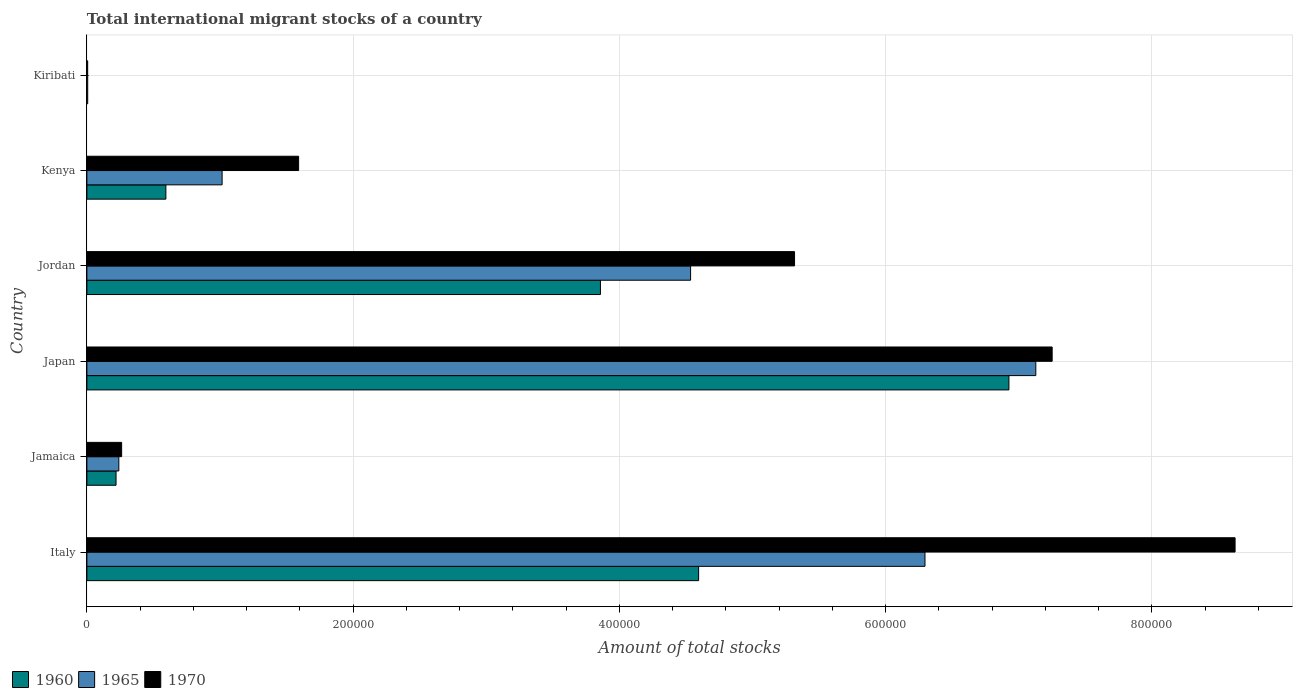How many groups of bars are there?
Provide a short and direct response. 6. Are the number of bars per tick equal to the number of legend labels?
Your answer should be very brief. Yes. Are the number of bars on each tick of the Y-axis equal?
Offer a very short reply. Yes. How many bars are there on the 1st tick from the top?
Your answer should be very brief. 3. What is the label of the 2nd group of bars from the top?
Provide a succinct answer. Kenya. In how many cases, is the number of bars for a given country not equal to the number of legend labels?
Make the answer very short. 0. What is the amount of total stocks in in 1960 in Jamaica?
Make the answer very short. 2.19e+04. Across all countries, what is the maximum amount of total stocks in in 1970?
Ensure brevity in your answer.  8.63e+05. Across all countries, what is the minimum amount of total stocks in in 1965?
Offer a very short reply. 602. In which country was the amount of total stocks in in 1970 minimum?
Keep it short and to the point. Kiribati. What is the total amount of total stocks in in 1970 in the graph?
Your response must be concise. 2.31e+06. What is the difference between the amount of total stocks in in 1960 in Italy and that in Kenya?
Keep it short and to the point. 4.00e+05. What is the difference between the amount of total stocks in in 1965 in Jordan and the amount of total stocks in in 1970 in Kenya?
Provide a short and direct response. 2.94e+05. What is the average amount of total stocks in in 1970 per country?
Offer a very short reply. 3.84e+05. What is the ratio of the amount of total stocks in in 1960 in Jamaica to that in Jordan?
Give a very brief answer. 0.06. Is the difference between the amount of total stocks in in 1960 in Jamaica and Kenya greater than the difference between the amount of total stocks in in 1970 in Jamaica and Kenya?
Make the answer very short. Yes. What is the difference between the highest and the second highest amount of total stocks in in 1960?
Your answer should be compact. 2.33e+05. What is the difference between the highest and the lowest amount of total stocks in in 1970?
Provide a succinct answer. 8.62e+05. What does the 1st bar from the top in Jordan represents?
Offer a very short reply. 1970. Is it the case that in every country, the sum of the amount of total stocks in in 1970 and amount of total stocks in in 1960 is greater than the amount of total stocks in in 1965?
Provide a succinct answer. Yes. How many bars are there?
Make the answer very short. 18. Are all the bars in the graph horizontal?
Ensure brevity in your answer.  Yes. How many countries are there in the graph?
Give a very brief answer. 6. What is the difference between two consecutive major ticks on the X-axis?
Offer a terse response. 2.00e+05. Are the values on the major ticks of X-axis written in scientific E-notation?
Your answer should be very brief. No. Does the graph contain any zero values?
Provide a succinct answer. No. How many legend labels are there?
Your response must be concise. 3. What is the title of the graph?
Offer a very short reply. Total international migrant stocks of a country. What is the label or title of the X-axis?
Your answer should be very brief. Amount of total stocks. What is the label or title of the Y-axis?
Make the answer very short. Country. What is the Amount of total stocks of 1960 in Italy?
Your answer should be very brief. 4.60e+05. What is the Amount of total stocks of 1965 in Italy?
Offer a terse response. 6.30e+05. What is the Amount of total stocks of 1970 in Italy?
Offer a terse response. 8.63e+05. What is the Amount of total stocks in 1960 in Jamaica?
Ensure brevity in your answer.  2.19e+04. What is the Amount of total stocks in 1965 in Jamaica?
Offer a very short reply. 2.40e+04. What is the Amount of total stocks of 1970 in Jamaica?
Keep it short and to the point. 2.61e+04. What is the Amount of total stocks of 1960 in Japan?
Keep it short and to the point. 6.93e+05. What is the Amount of total stocks in 1965 in Japan?
Make the answer very short. 7.13e+05. What is the Amount of total stocks in 1970 in Japan?
Make the answer very short. 7.25e+05. What is the Amount of total stocks in 1960 in Jordan?
Offer a very short reply. 3.86e+05. What is the Amount of total stocks in 1965 in Jordan?
Your answer should be very brief. 4.54e+05. What is the Amount of total stocks in 1970 in Jordan?
Offer a very short reply. 5.32e+05. What is the Amount of total stocks in 1960 in Kenya?
Your answer should be very brief. 5.93e+04. What is the Amount of total stocks of 1965 in Kenya?
Keep it short and to the point. 1.02e+05. What is the Amount of total stocks of 1970 in Kenya?
Your response must be concise. 1.59e+05. What is the Amount of total stocks in 1960 in Kiribati?
Your answer should be compact. 610. What is the Amount of total stocks in 1965 in Kiribati?
Your answer should be compact. 602. What is the Amount of total stocks of 1970 in Kiribati?
Offer a very short reply. 587. Across all countries, what is the maximum Amount of total stocks in 1960?
Your answer should be very brief. 6.93e+05. Across all countries, what is the maximum Amount of total stocks of 1965?
Give a very brief answer. 7.13e+05. Across all countries, what is the maximum Amount of total stocks in 1970?
Your response must be concise. 8.63e+05. Across all countries, what is the minimum Amount of total stocks of 1960?
Offer a terse response. 610. Across all countries, what is the minimum Amount of total stocks in 1965?
Give a very brief answer. 602. Across all countries, what is the minimum Amount of total stocks in 1970?
Offer a terse response. 587. What is the total Amount of total stocks of 1960 in the graph?
Give a very brief answer. 1.62e+06. What is the total Amount of total stocks of 1965 in the graph?
Provide a short and direct response. 1.92e+06. What is the total Amount of total stocks of 1970 in the graph?
Provide a short and direct response. 2.31e+06. What is the difference between the Amount of total stocks in 1960 in Italy and that in Jamaica?
Your answer should be very brief. 4.38e+05. What is the difference between the Amount of total stocks of 1965 in Italy and that in Jamaica?
Your answer should be very brief. 6.06e+05. What is the difference between the Amount of total stocks in 1970 in Italy and that in Jamaica?
Make the answer very short. 8.36e+05. What is the difference between the Amount of total stocks in 1960 in Italy and that in Japan?
Offer a terse response. -2.33e+05. What is the difference between the Amount of total stocks of 1965 in Italy and that in Japan?
Make the answer very short. -8.33e+04. What is the difference between the Amount of total stocks in 1970 in Italy and that in Japan?
Your response must be concise. 1.37e+05. What is the difference between the Amount of total stocks in 1960 in Italy and that in Jordan?
Provide a succinct answer. 7.38e+04. What is the difference between the Amount of total stocks in 1965 in Italy and that in Jordan?
Your response must be concise. 1.76e+05. What is the difference between the Amount of total stocks in 1970 in Italy and that in Jordan?
Make the answer very short. 3.31e+05. What is the difference between the Amount of total stocks in 1960 in Italy and that in Kenya?
Your answer should be compact. 4.00e+05. What is the difference between the Amount of total stocks in 1965 in Italy and that in Kenya?
Keep it short and to the point. 5.28e+05. What is the difference between the Amount of total stocks in 1970 in Italy and that in Kenya?
Give a very brief answer. 7.04e+05. What is the difference between the Amount of total stocks in 1960 in Italy and that in Kiribati?
Your answer should be compact. 4.59e+05. What is the difference between the Amount of total stocks in 1965 in Italy and that in Kiribati?
Give a very brief answer. 6.29e+05. What is the difference between the Amount of total stocks in 1970 in Italy and that in Kiribati?
Make the answer very short. 8.62e+05. What is the difference between the Amount of total stocks of 1960 in Jamaica and that in Japan?
Provide a short and direct response. -6.71e+05. What is the difference between the Amount of total stocks of 1965 in Jamaica and that in Japan?
Your answer should be compact. -6.89e+05. What is the difference between the Amount of total stocks in 1970 in Jamaica and that in Japan?
Ensure brevity in your answer.  -6.99e+05. What is the difference between the Amount of total stocks of 1960 in Jamaica and that in Jordan?
Ensure brevity in your answer.  -3.64e+05. What is the difference between the Amount of total stocks of 1965 in Jamaica and that in Jordan?
Provide a succinct answer. -4.30e+05. What is the difference between the Amount of total stocks in 1970 in Jamaica and that in Jordan?
Your answer should be very brief. -5.06e+05. What is the difference between the Amount of total stocks in 1960 in Jamaica and that in Kenya?
Offer a terse response. -3.74e+04. What is the difference between the Amount of total stocks in 1965 in Jamaica and that in Kenya?
Offer a terse response. -7.76e+04. What is the difference between the Amount of total stocks of 1970 in Jamaica and that in Kenya?
Offer a very short reply. -1.33e+05. What is the difference between the Amount of total stocks in 1960 in Jamaica and that in Kiribati?
Offer a very short reply. 2.13e+04. What is the difference between the Amount of total stocks in 1965 in Jamaica and that in Kiribati?
Make the answer very short. 2.34e+04. What is the difference between the Amount of total stocks in 1970 in Jamaica and that in Kiribati?
Offer a terse response. 2.55e+04. What is the difference between the Amount of total stocks in 1960 in Japan and that in Jordan?
Provide a succinct answer. 3.07e+05. What is the difference between the Amount of total stocks in 1965 in Japan and that in Jordan?
Offer a terse response. 2.59e+05. What is the difference between the Amount of total stocks of 1970 in Japan and that in Jordan?
Give a very brief answer. 1.94e+05. What is the difference between the Amount of total stocks in 1960 in Japan and that in Kenya?
Your response must be concise. 6.33e+05. What is the difference between the Amount of total stocks of 1965 in Japan and that in Kenya?
Provide a succinct answer. 6.11e+05. What is the difference between the Amount of total stocks in 1970 in Japan and that in Kenya?
Keep it short and to the point. 5.66e+05. What is the difference between the Amount of total stocks in 1960 in Japan and that in Kiribati?
Make the answer very short. 6.92e+05. What is the difference between the Amount of total stocks in 1965 in Japan and that in Kiribati?
Provide a succinct answer. 7.12e+05. What is the difference between the Amount of total stocks of 1970 in Japan and that in Kiribati?
Give a very brief answer. 7.25e+05. What is the difference between the Amount of total stocks in 1960 in Jordan and that in Kenya?
Offer a terse response. 3.26e+05. What is the difference between the Amount of total stocks of 1965 in Jordan and that in Kenya?
Your answer should be very brief. 3.52e+05. What is the difference between the Amount of total stocks of 1970 in Jordan and that in Kenya?
Provide a succinct answer. 3.73e+05. What is the difference between the Amount of total stocks of 1960 in Jordan and that in Kiribati?
Your answer should be compact. 3.85e+05. What is the difference between the Amount of total stocks of 1965 in Jordan and that in Kiribati?
Offer a terse response. 4.53e+05. What is the difference between the Amount of total stocks of 1970 in Jordan and that in Kiribati?
Provide a short and direct response. 5.31e+05. What is the difference between the Amount of total stocks in 1960 in Kenya and that in Kiribati?
Provide a short and direct response. 5.87e+04. What is the difference between the Amount of total stocks of 1965 in Kenya and that in Kiribati?
Your answer should be very brief. 1.01e+05. What is the difference between the Amount of total stocks in 1970 in Kenya and that in Kiribati?
Make the answer very short. 1.58e+05. What is the difference between the Amount of total stocks in 1960 in Italy and the Amount of total stocks in 1965 in Jamaica?
Your response must be concise. 4.36e+05. What is the difference between the Amount of total stocks of 1960 in Italy and the Amount of total stocks of 1970 in Jamaica?
Keep it short and to the point. 4.33e+05. What is the difference between the Amount of total stocks of 1965 in Italy and the Amount of total stocks of 1970 in Jamaica?
Your answer should be compact. 6.03e+05. What is the difference between the Amount of total stocks in 1960 in Italy and the Amount of total stocks in 1965 in Japan?
Keep it short and to the point. -2.53e+05. What is the difference between the Amount of total stocks in 1960 in Italy and the Amount of total stocks in 1970 in Japan?
Keep it short and to the point. -2.66e+05. What is the difference between the Amount of total stocks in 1965 in Italy and the Amount of total stocks in 1970 in Japan?
Keep it short and to the point. -9.55e+04. What is the difference between the Amount of total stocks in 1960 in Italy and the Amount of total stocks in 1965 in Jordan?
Your response must be concise. 6032. What is the difference between the Amount of total stocks in 1960 in Italy and the Amount of total stocks in 1970 in Jordan?
Your response must be concise. -7.21e+04. What is the difference between the Amount of total stocks in 1965 in Italy and the Amount of total stocks in 1970 in Jordan?
Your answer should be very brief. 9.80e+04. What is the difference between the Amount of total stocks in 1960 in Italy and the Amount of total stocks in 1965 in Kenya?
Your answer should be compact. 3.58e+05. What is the difference between the Amount of total stocks in 1960 in Italy and the Amount of total stocks in 1970 in Kenya?
Offer a terse response. 3.01e+05. What is the difference between the Amount of total stocks of 1965 in Italy and the Amount of total stocks of 1970 in Kenya?
Keep it short and to the point. 4.71e+05. What is the difference between the Amount of total stocks in 1960 in Italy and the Amount of total stocks in 1965 in Kiribati?
Provide a short and direct response. 4.59e+05. What is the difference between the Amount of total stocks of 1960 in Italy and the Amount of total stocks of 1970 in Kiribati?
Your answer should be very brief. 4.59e+05. What is the difference between the Amount of total stocks in 1965 in Italy and the Amount of total stocks in 1970 in Kiribati?
Your answer should be compact. 6.29e+05. What is the difference between the Amount of total stocks in 1960 in Jamaica and the Amount of total stocks in 1965 in Japan?
Ensure brevity in your answer.  -6.91e+05. What is the difference between the Amount of total stocks of 1960 in Jamaica and the Amount of total stocks of 1970 in Japan?
Give a very brief answer. -7.03e+05. What is the difference between the Amount of total stocks in 1965 in Jamaica and the Amount of total stocks in 1970 in Japan?
Your response must be concise. -7.01e+05. What is the difference between the Amount of total stocks of 1960 in Jamaica and the Amount of total stocks of 1965 in Jordan?
Your answer should be compact. -4.32e+05. What is the difference between the Amount of total stocks of 1960 in Jamaica and the Amount of total stocks of 1970 in Jordan?
Ensure brevity in your answer.  -5.10e+05. What is the difference between the Amount of total stocks of 1965 in Jamaica and the Amount of total stocks of 1970 in Jordan?
Ensure brevity in your answer.  -5.08e+05. What is the difference between the Amount of total stocks of 1960 in Jamaica and the Amount of total stocks of 1965 in Kenya?
Give a very brief answer. -7.97e+04. What is the difference between the Amount of total stocks of 1960 in Jamaica and the Amount of total stocks of 1970 in Kenya?
Provide a short and direct response. -1.37e+05. What is the difference between the Amount of total stocks of 1965 in Jamaica and the Amount of total stocks of 1970 in Kenya?
Your response must be concise. -1.35e+05. What is the difference between the Amount of total stocks in 1960 in Jamaica and the Amount of total stocks in 1965 in Kiribati?
Provide a succinct answer. 2.13e+04. What is the difference between the Amount of total stocks in 1960 in Jamaica and the Amount of total stocks in 1970 in Kiribati?
Ensure brevity in your answer.  2.13e+04. What is the difference between the Amount of total stocks of 1965 in Jamaica and the Amount of total stocks of 1970 in Kiribati?
Provide a short and direct response. 2.34e+04. What is the difference between the Amount of total stocks in 1960 in Japan and the Amount of total stocks in 1965 in Jordan?
Provide a succinct answer. 2.39e+05. What is the difference between the Amount of total stocks of 1960 in Japan and the Amount of total stocks of 1970 in Jordan?
Ensure brevity in your answer.  1.61e+05. What is the difference between the Amount of total stocks of 1965 in Japan and the Amount of total stocks of 1970 in Jordan?
Your response must be concise. 1.81e+05. What is the difference between the Amount of total stocks of 1960 in Japan and the Amount of total stocks of 1965 in Kenya?
Your answer should be very brief. 5.91e+05. What is the difference between the Amount of total stocks of 1960 in Japan and the Amount of total stocks of 1970 in Kenya?
Keep it short and to the point. 5.34e+05. What is the difference between the Amount of total stocks in 1965 in Japan and the Amount of total stocks in 1970 in Kenya?
Your response must be concise. 5.54e+05. What is the difference between the Amount of total stocks in 1960 in Japan and the Amount of total stocks in 1965 in Kiribati?
Keep it short and to the point. 6.92e+05. What is the difference between the Amount of total stocks in 1960 in Japan and the Amount of total stocks in 1970 in Kiribati?
Offer a terse response. 6.92e+05. What is the difference between the Amount of total stocks of 1965 in Japan and the Amount of total stocks of 1970 in Kiribati?
Your response must be concise. 7.12e+05. What is the difference between the Amount of total stocks in 1960 in Jordan and the Amount of total stocks in 1965 in Kenya?
Your answer should be very brief. 2.84e+05. What is the difference between the Amount of total stocks in 1960 in Jordan and the Amount of total stocks in 1970 in Kenya?
Provide a short and direct response. 2.27e+05. What is the difference between the Amount of total stocks of 1965 in Jordan and the Amount of total stocks of 1970 in Kenya?
Your response must be concise. 2.94e+05. What is the difference between the Amount of total stocks in 1960 in Jordan and the Amount of total stocks in 1965 in Kiribati?
Offer a very short reply. 3.85e+05. What is the difference between the Amount of total stocks in 1960 in Jordan and the Amount of total stocks in 1970 in Kiribati?
Your answer should be compact. 3.85e+05. What is the difference between the Amount of total stocks in 1965 in Jordan and the Amount of total stocks in 1970 in Kiribati?
Offer a terse response. 4.53e+05. What is the difference between the Amount of total stocks in 1960 in Kenya and the Amount of total stocks in 1965 in Kiribati?
Your answer should be compact. 5.87e+04. What is the difference between the Amount of total stocks of 1960 in Kenya and the Amount of total stocks of 1970 in Kiribati?
Keep it short and to the point. 5.87e+04. What is the difference between the Amount of total stocks of 1965 in Kenya and the Amount of total stocks of 1970 in Kiribati?
Your answer should be very brief. 1.01e+05. What is the average Amount of total stocks of 1960 per country?
Provide a succinct answer. 2.70e+05. What is the average Amount of total stocks of 1965 per country?
Make the answer very short. 3.20e+05. What is the average Amount of total stocks in 1970 per country?
Your answer should be compact. 3.84e+05. What is the difference between the Amount of total stocks in 1960 and Amount of total stocks in 1965 in Italy?
Your answer should be very brief. -1.70e+05. What is the difference between the Amount of total stocks of 1960 and Amount of total stocks of 1970 in Italy?
Provide a short and direct response. -4.03e+05. What is the difference between the Amount of total stocks in 1965 and Amount of total stocks in 1970 in Italy?
Your answer should be compact. -2.33e+05. What is the difference between the Amount of total stocks in 1960 and Amount of total stocks in 1965 in Jamaica?
Your answer should be compact. -2090. What is the difference between the Amount of total stocks of 1960 and Amount of total stocks of 1970 in Jamaica?
Offer a terse response. -4196. What is the difference between the Amount of total stocks of 1965 and Amount of total stocks of 1970 in Jamaica?
Offer a very short reply. -2106. What is the difference between the Amount of total stocks of 1960 and Amount of total stocks of 1965 in Japan?
Ensure brevity in your answer.  -2.02e+04. What is the difference between the Amount of total stocks in 1960 and Amount of total stocks in 1970 in Japan?
Ensure brevity in your answer.  -3.25e+04. What is the difference between the Amount of total stocks in 1965 and Amount of total stocks in 1970 in Japan?
Offer a terse response. -1.23e+04. What is the difference between the Amount of total stocks of 1960 and Amount of total stocks of 1965 in Jordan?
Provide a short and direct response. -6.77e+04. What is the difference between the Amount of total stocks in 1960 and Amount of total stocks in 1970 in Jordan?
Ensure brevity in your answer.  -1.46e+05. What is the difference between the Amount of total stocks of 1965 and Amount of total stocks of 1970 in Jordan?
Make the answer very short. -7.81e+04. What is the difference between the Amount of total stocks in 1960 and Amount of total stocks in 1965 in Kenya?
Your answer should be very brief. -4.23e+04. What is the difference between the Amount of total stocks in 1960 and Amount of total stocks in 1970 in Kenya?
Your answer should be very brief. -9.97e+04. What is the difference between the Amount of total stocks in 1965 and Amount of total stocks in 1970 in Kenya?
Offer a terse response. -5.75e+04. What is the difference between the Amount of total stocks in 1960 and Amount of total stocks in 1970 in Kiribati?
Your response must be concise. 23. What is the difference between the Amount of total stocks in 1965 and Amount of total stocks in 1970 in Kiribati?
Provide a succinct answer. 15. What is the ratio of the Amount of total stocks of 1960 in Italy to that in Jamaica?
Give a very brief answer. 20.98. What is the ratio of the Amount of total stocks of 1965 in Italy to that in Jamaica?
Your response must be concise. 26.24. What is the ratio of the Amount of total stocks of 1970 in Italy to that in Jamaica?
Your response must be concise. 33.05. What is the ratio of the Amount of total stocks in 1960 in Italy to that in Japan?
Your response must be concise. 0.66. What is the ratio of the Amount of total stocks in 1965 in Italy to that in Japan?
Your answer should be compact. 0.88. What is the ratio of the Amount of total stocks in 1970 in Italy to that in Japan?
Your answer should be compact. 1.19. What is the ratio of the Amount of total stocks in 1960 in Italy to that in Jordan?
Ensure brevity in your answer.  1.19. What is the ratio of the Amount of total stocks of 1965 in Italy to that in Jordan?
Ensure brevity in your answer.  1.39. What is the ratio of the Amount of total stocks of 1970 in Italy to that in Jordan?
Offer a very short reply. 1.62. What is the ratio of the Amount of total stocks of 1960 in Italy to that in Kenya?
Ensure brevity in your answer.  7.75. What is the ratio of the Amount of total stocks of 1965 in Italy to that in Kenya?
Keep it short and to the point. 6.2. What is the ratio of the Amount of total stocks in 1970 in Italy to that in Kenya?
Offer a terse response. 5.42. What is the ratio of the Amount of total stocks in 1960 in Italy to that in Kiribati?
Ensure brevity in your answer.  753.37. What is the ratio of the Amount of total stocks of 1965 in Italy to that in Kiribati?
Provide a short and direct response. 1045.84. What is the ratio of the Amount of total stocks in 1970 in Italy to that in Kiribati?
Your answer should be very brief. 1469.43. What is the ratio of the Amount of total stocks in 1960 in Jamaica to that in Japan?
Offer a terse response. 0.03. What is the ratio of the Amount of total stocks of 1965 in Jamaica to that in Japan?
Your answer should be compact. 0.03. What is the ratio of the Amount of total stocks of 1970 in Jamaica to that in Japan?
Offer a terse response. 0.04. What is the ratio of the Amount of total stocks of 1960 in Jamaica to that in Jordan?
Your answer should be very brief. 0.06. What is the ratio of the Amount of total stocks in 1965 in Jamaica to that in Jordan?
Keep it short and to the point. 0.05. What is the ratio of the Amount of total stocks in 1970 in Jamaica to that in Jordan?
Offer a terse response. 0.05. What is the ratio of the Amount of total stocks of 1960 in Jamaica to that in Kenya?
Give a very brief answer. 0.37. What is the ratio of the Amount of total stocks in 1965 in Jamaica to that in Kenya?
Offer a very short reply. 0.24. What is the ratio of the Amount of total stocks in 1970 in Jamaica to that in Kenya?
Give a very brief answer. 0.16. What is the ratio of the Amount of total stocks in 1960 in Jamaica to that in Kiribati?
Provide a short and direct response. 35.91. What is the ratio of the Amount of total stocks of 1965 in Jamaica to that in Kiribati?
Provide a short and direct response. 39.86. What is the ratio of the Amount of total stocks in 1970 in Jamaica to that in Kiribati?
Provide a succinct answer. 44.46. What is the ratio of the Amount of total stocks in 1960 in Japan to that in Jordan?
Your response must be concise. 1.8. What is the ratio of the Amount of total stocks of 1965 in Japan to that in Jordan?
Provide a succinct answer. 1.57. What is the ratio of the Amount of total stocks of 1970 in Japan to that in Jordan?
Provide a short and direct response. 1.36. What is the ratio of the Amount of total stocks in 1960 in Japan to that in Kenya?
Keep it short and to the point. 11.67. What is the ratio of the Amount of total stocks in 1965 in Japan to that in Kenya?
Make the answer very short. 7.02. What is the ratio of the Amount of total stocks in 1970 in Japan to that in Kenya?
Your answer should be compact. 4.56. What is the ratio of the Amount of total stocks in 1960 in Japan to that in Kiribati?
Make the answer very short. 1135.49. What is the ratio of the Amount of total stocks of 1965 in Japan to that in Kiribati?
Your response must be concise. 1184.14. What is the ratio of the Amount of total stocks in 1970 in Japan to that in Kiribati?
Offer a terse response. 1235.33. What is the ratio of the Amount of total stocks of 1960 in Jordan to that in Kenya?
Offer a very short reply. 6.5. What is the ratio of the Amount of total stocks in 1965 in Jordan to that in Kenya?
Offer a terse response. 4.46. What is the ratio of the Amount of total stocks in 1970 in Jordan to that in Kenya?
Give a very brief answer. 3.34. What is the ratio of the Amount of total stocks of 1960 in Jordan to that in Kiribati?
Offer a very short reply. 632.44. What is the ratio of the Amount of total stocks of 1965 in Jordan to that in Kiribati?
Provide a succinct answer. 753.36. What is the ratio of the Amount of total stocks of 1970 in Jordan to that in Kiribati?
Your answer should be compact. 905.65. What is the ratio of the Amount of total stocks in 1960 in Kenya to that in Kiribati?
Give a very brief answer. 97.26. What is the ratio of the Amount of total stocks of 1965 in Kenya to that in Kiribati?
Ensure brevity in your answer.  168.74. What is the ratio of the Amount of total stocks of 1970 in Kenya to that in Kiribati?
Make the answer very short. 270.94. What is the difference between the highest and the second highest Amount of total stocks of 1960?
Keep it short and to the point. 2.33e+05. What is the difference between the highest and the second highest Amount of total stocks of 1965?
Offer a very short reply. 8.33e+04. What is the difference between the highest and the second highest Amount of total stocks in 1970?
Your response must be concise. 1.37e+05. What is the difference between the highest and the lowest Amount of total stocks in 1960?
Your answer should be compact. 6.92e+05. What is the difference between the highest and the lowest Amount of total stocks of 1965?
Your answer should be very brief. 7.12e+05. What is the difference between the highest and the lowest Amount of total stocks in 1970?
Ensure brevity in your answer.  8.62e+05. 